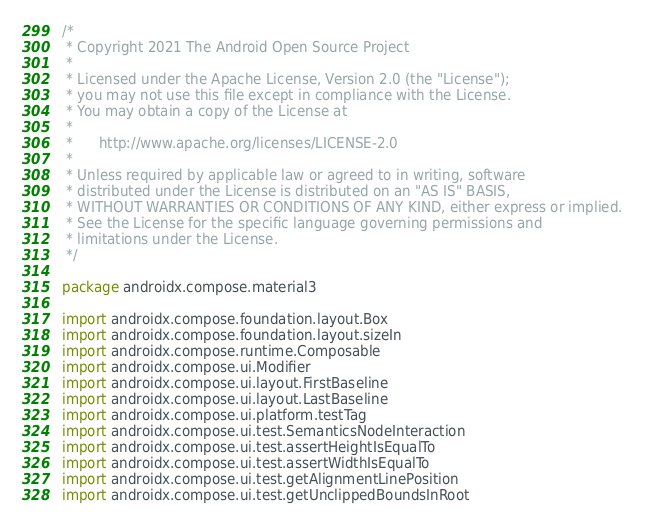Convert code to text. <code><loc_0><loc_0><loc_500><loc_500><_Kotlin_>/*
 * Copyright 2021 The Android Open Source Project
 *
 * Licensed under the Apache License, Version 2.0 (the "License");
 * you may not use this file except in compliance with the License.
 * You may obtain a copy of the License at
 *
 *      http://www.apache.org/licenses/LICENSE-2.0
 *
 * Unless required by applicable law or agreed to in writing, software
 * distributed under the License is distributed on an "AS IS" BASIS,
 * WITHOUT WARRANTIES OR CONDITIONS OF ANY KIND, either express or implied.
 * See the License for the specific language governing permissions and
 * limitations under the License.
 */

package androidx.compose.material3

import androidx.compose.foundation.layout.Box
import androidx.compose.foundation.layout.sizeIn
import androidx.compose.runtime.Composable
import androidx.compose.ui.Modifier
import androidx.compose.ui.layout.FirstBaseline
import androidx.compose.ui.layout.LastBaseline
import androidx.compose.ui.platform.testTag
import androidx.compose.ui.test.SemanticsNodeInteraction
import androidx.compose.ui.test.assertHeightIsEqualTo
import androidx.compose.ui.test.assertWidthIsEqualTo
import androidx.compose.ui.test.getAlignmentLinePosition
import androidx.compose.ui.test.getUnclippedBoundsInRoot</code> 